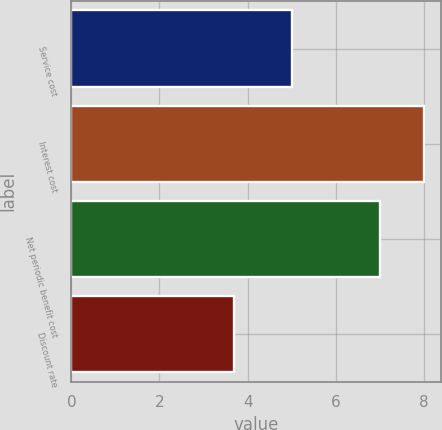Convert chart. <chart><loc_0><loc_0><loc_500><loc_500><bar_chart><fcel>Service cost<fcel>Interest cost<fcel>Net periodic benefit cost<fcel>Discount rate<nl><fcel>5<fcel>8<fcel>7<fcel>3.7<nl></chart> 